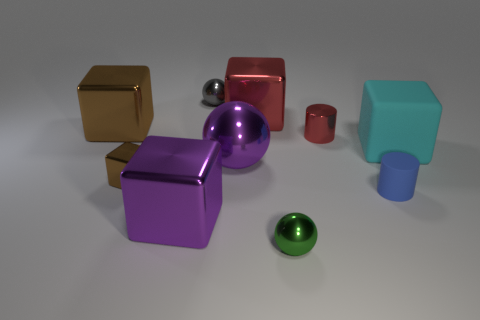Subtract all purple cubes. How many cubes are left? 4 Subtract all cyan blocks. How many blocks are left? 4 Subtract all gray cubes. Subtract all yellow spheres. How many cubes are left? 5 Subtract all spheres. How many objects are left? 7 Add 1 big spheres. How many big spheres are left? 2 Add 2 tiny gray spheres. How many tiny gray spheres exist? 3 Subtract 0 blue spheres. How many objects are left? 10 Subtract all green metallic spheres. Subtract all small red objects. How many objects are left? 8 